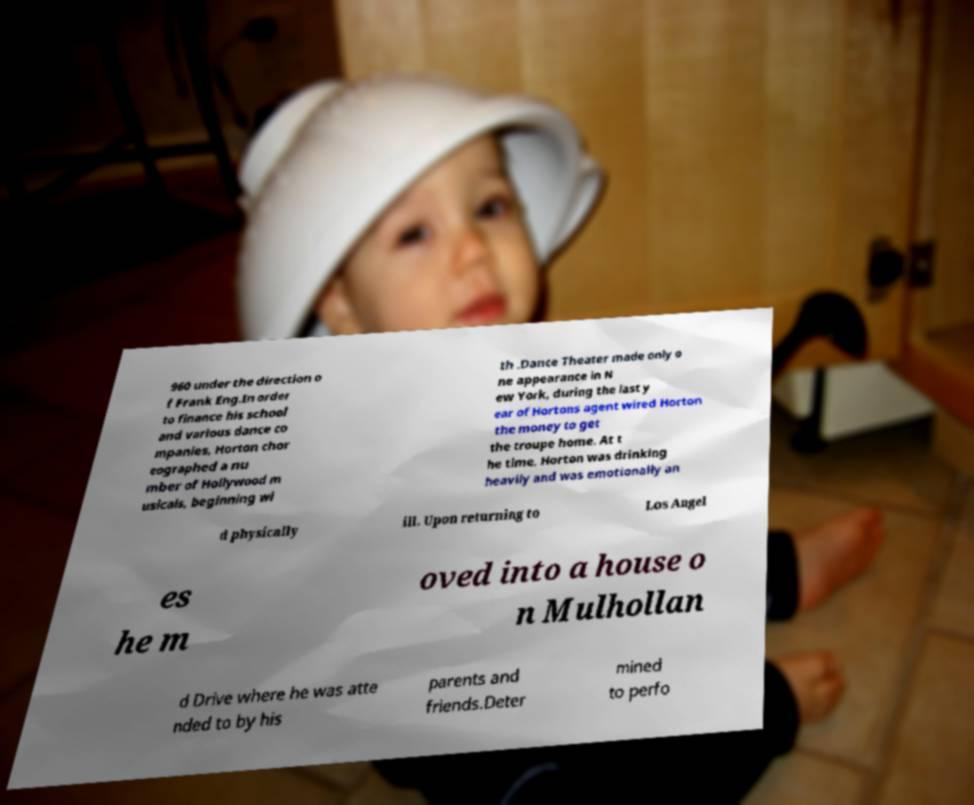There's text embedded in this image that I need extracted. Can you transcribe it verbatim? 960 under the direction o f Frank Eng.In order to finance his school and various dance co mpanies, Horton chor eographed a nu mber of Hollywood m usicals, beginning wi th .Dance Theater made only o ne appearance in N ew York, during the last y ear of Hortons agent wired Horton the money to get the troupe home. At t he time, Horton was drinking heavily and was emotionally an d physically ill. Upon returning to Los Angel es he m oved into a house o n Mulhollan d Drive where he was atte nded to by his parents and friends.Deter mined to perfo 